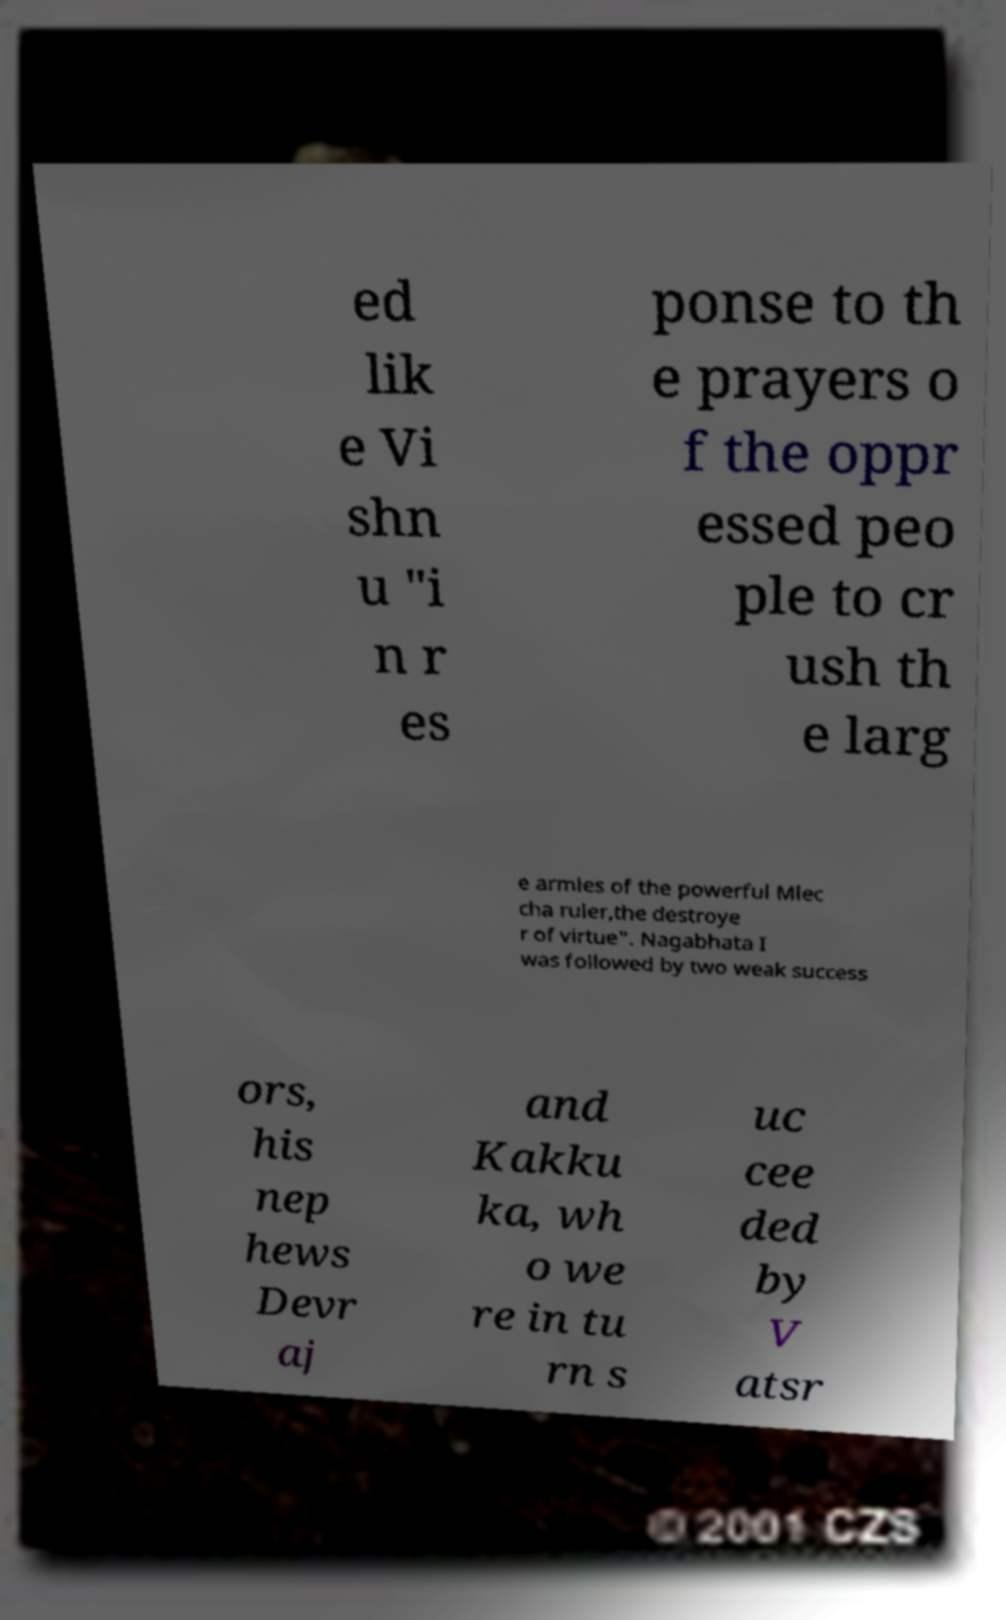Can you accurately transcribe the text from the provided image for me? ed lik e Vi shn u "i n r es ponse to th e prayers o f the oppr essed peo ple to cr ush th e larg e armies of the powerful Mlec cha ruler,the destroye r of virtue". Nagabhata I was followed by two weak success ors, his nep hews Devr aj and Kakku ka, wh o we re in tu rn s uc cee ded by V atsr 